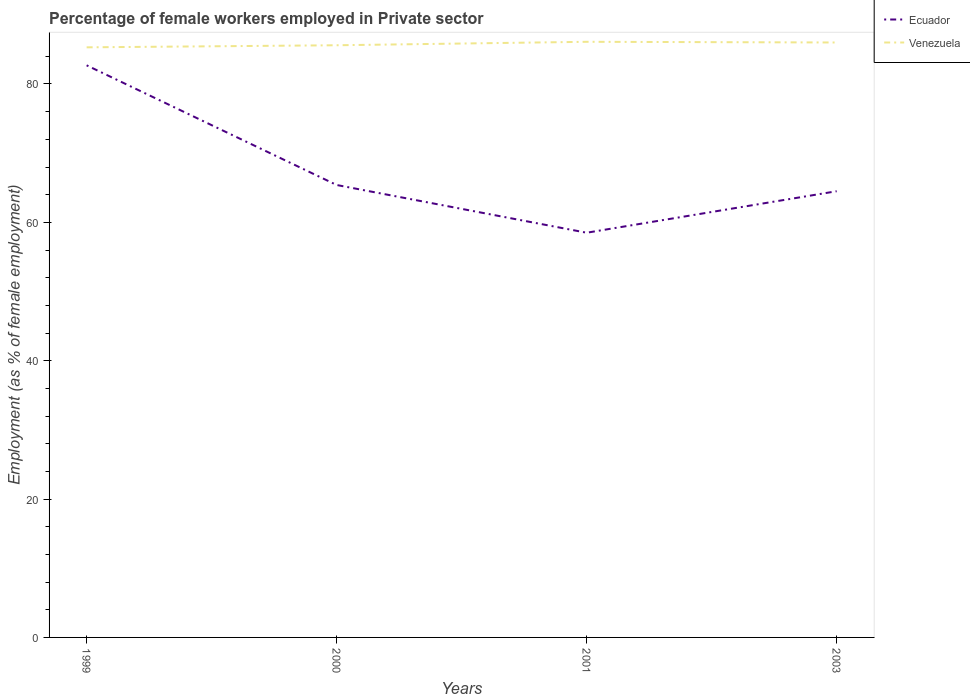How many different coloured lines are there?
Your response must be concise. 2. Does the line corresponding to Venezuela intersect with the line corresponding to Ecuador?
Give a very brief answer. No. Across all years, what is the maximum percentage of females employed in Private sector in Ecuador?
Make the answer very short. 58.5. What is the total percentage of females employed in Private sector in Venezuela in the graph?
Offer a very short reply. -0.8. What is the difference between the highest and the second highest percentage of females employed in Private sector in Ecuador?
Your response must be concise. 24.2. What is the difference between the highest and the lowest percentage of females employed in Private sector in Ecuador?
Your answer should be compact. 1. Is the percentage of females employed in Private sector in Ecuador strictly greater than the percentage of females employed in Private sector in Venezuela over the years?
Make the answer very short. Yes. How many lines are there?
Give a very brief answer. 2. What is the difference between two consecutive major ticks on the Y-axis?
Your response must be concise. 20. Are the values on the major ticks of Y-axis written in scientific E-notation?
Provide a succinct answer. No. Does the graph contain any zero values?
Make the answer very short. No. Where does the legend appear in the graph?
Provide a short and direct response. Top right. How are the legend labels stacked?
Keep it short and to the point. Vertical. What is the title of the graph?
Your answer should be compact. Percentage of female workers employed in Private sector. Does "Russian Federation" appear as one of the legend labels in the graph?
Provide a succinct answer. No. What is the label or title of the X-axis?
Offer a terse response. Years. What is the label or title of the Y-axis?
Provide a short and direct response. Employment (as % of female employment). What is the Employment (as % of female employment) in Ecuador in 1999?
Ensure brevity in your answer.  82.7. What is the Employment (as % of female employment) of Venezuela in 1999?
Keep it short and to the point. 85.3. What is the Employment (as % of female employment) of Ecuador in 2000?
Offer a terse response. 65.4. What is the Employment (as % of female employment) of Venezuela in 2000?
Your answer should be compact. 85.6. What is the Employment (as % of female employment) of Ecuador in 2001?
Ensure brevity in your answer.  58.5. What is the Employment (as % of female employment) in Venezuela in 2001?
Keep it short and to the point. 86.1. What is the Employment (as % of female employment) in Ecuador in 2003?
Your response must be concise. 64.5. Across all years, what is the maximum Employment (as % of female employment) of Ecuador?
Give a very brief answer. 82.7. Across all years, what is the maximum Employment (as % of female employment) in Venezuela?
Provide a succinct answer. 86.1. Across all years, what is the minimum Employment (as % of female employment) in Ecuador?
Offer a very short reply. 58.5. Across all years, what is the minimum Employment (as % of female employment) in Venezuela?
Offer a terse response. 85.3. What is the total Employment (as % of female employment) in Ecuador in the graph?
Your response must be concise. 271.1. What is the total Employment (as % of female employment) in Venezuela in the graph?
Keep it short and to the point. 343. What is the difference between the Employment (as % of female employment) in Venezuela in 1999 and that in 2000?
Keep it short and to the point. -0.3. What is the difference between the Employment (as % of female employment) of Ecuador in 1999 and that in 2001?
Your answer should be compact. 24.2. What is the difference between the Employment (as % of female employment) of Ecuador in 1999 and that in 2003?
Keep it short and to the point. 18.2. What is the difference between the Employment (as % of female employment) of Venezuela in 2000 and that in 2001?
Your response must be concise. -0.5. What is the difference between the Employment (as % of female employment) in Ecuador in 2001 and that in 2003?
Keep it short and to the point. -6. What is the difference between the Employment (as % of female employment) of Venezuela in 2001 and that in 2003?
Make the answer very short. 0.1. What is the difference between the Employment (as % of female employment) of Ecuador in 1999 and the Employment (as % of female employment) of Venezuela in 2000?
Offer a terse response. -2.9. What is the difference between the Employment (as % of female employment) of Ecuador in 1999 and the Employment (as % of female employment) of Venezuela in 2001?
Your answer should be very brief. -3.4. What is the difference between the Employment (as % of female employment) of Ecuador in 1999 and the Employment (as % of female employment) of Venezuela in 2003?
Offer a terse response. -3.3. What is the difference between the Employment (as % of female employment) in Ecuador in 2000 and the Employment (as % of female employment) in Venezuela in 2001?
Your answer should be compact. -20.7. What is the difference between the Employment (as % of female employment) of Ecuador in 2000 and the Employment (as % of female employment) of Venezuela in 2003?
Provide a succinct answer. -20.6. What is the difference between the Employment (as % of female employment) of Ecuador in 2001 and the Employment (as % of female employment) of Venezuela in 2003?
Offer a very short reply. -27.5. What is the average Employment (as % of female employment) in Ecuador per year?
Your answer should be very brief. 67.78. What is the average Employment (as % of female employment) of Venezuela per year?
Give a very brief answer. 85.75. In the year 1999, what is the difference between the Employment (as % of female employment) of Ecuador and Employment (as % of female employment) of Venezuela?
Your answer should be very brief. -2.6. In the year 2000, what is the difference between the Employment (as % of female employment) in Ecuador and Employment (as % of female employment) in Venezuela?
Offer a very short reply. -20.2. In the year 2001, what is the difference between the Employment (as % of female employment) in Ecuador and Employment (as % of female employment) in Venezuela?
Your response must be concise. -27.6. In the year 2003, what is the difference between the Employment (as % of female employment) of Ecuador and Employment (as % of female employment) of Venezuela?
Your answer should be very brief. -21.5. What is the ratio of the Employment (as % of female employment) of Ecuador in 1999 to that in 2000?
Your response must be concise. 1.26. What is the ratio of the Employment (as % of female employment) of Venezuela in 1999 to that in 2000?
Your answer should be compact. 1. What is the ratio of the Employment (as % of female employment) of Ecuador in 1999 to that in 2001?
Give a very brief answer. 1.41. What is the ratio of the Employment (as % of female employment) of Venezuela in 1999 to that in 2001?
Your response must be concise. 0.99. What is the ratio of the Employment (as % of female employment) in Ecuador in 1999 to that in 2003?
Offer a very short reply. 1.28. What is the ratio of the Employment (as % of female employment) in Ecuador in 2000 to that in 2001?
Give a very brief answer. 1.12. What is the ratio of the Employment (as % of female employment) of Venezuela in 2000 to that in 2001?
Your answer should be compact. 0.99. What is the ratio of the Employment (as % of female employment) in Ecuador in 2001 to that in 2003?
Offer a very short reply. 0.91. What is the difference between the highest and the second highest Employment (as % of female employment) in Venezuela?
Provide a succinct answer. 0.1. What is the difference between the highest and the lowest Employment (as % of female employment) in Ecuador?
Offer a very short reply. 24.2. What is the difference between the highest and the lowest Employment (as % of female employment) in Venezuela?
Give a very brief answer. 0.8. 